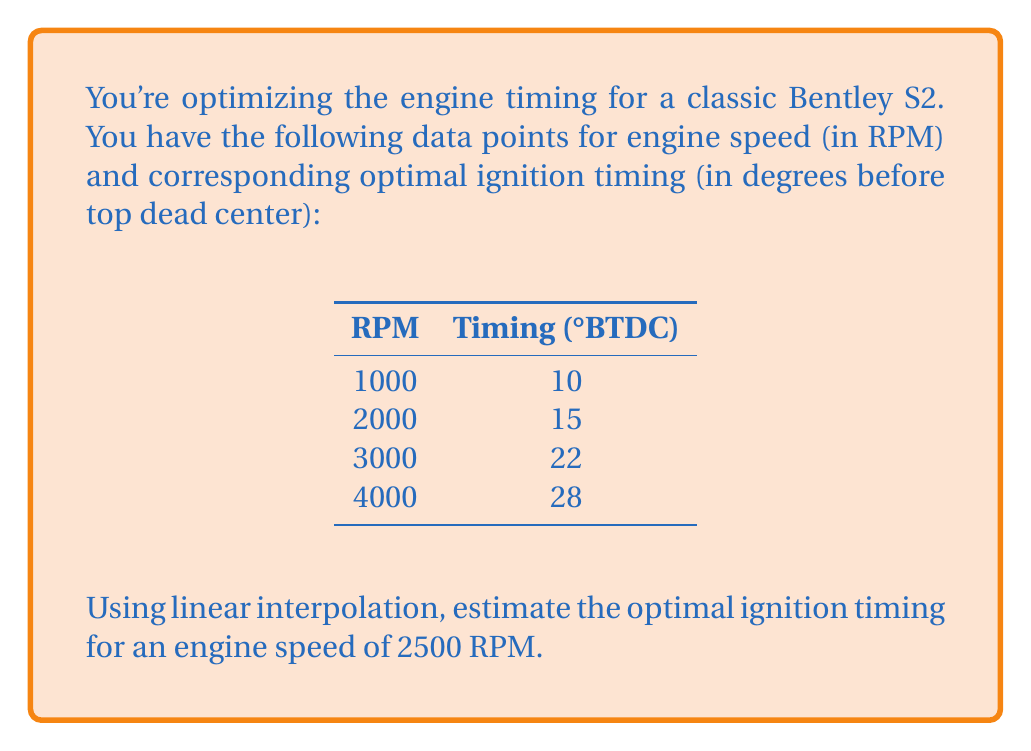Could you help me with this problem? To solve this problem, we'll use linear interpolation between the two closest data points:

1. Identify the two closest data points:
   - Lower point: (2000 RPM, 15°BTDC)
   - Upper point: (3000 RPM, 22°BTDC)

2. Set up the linear interpolation formula:
   $$y = y_1 + \frac{(x - x_1)(y_2 - y_1)}{(x_2 - x_1)}$$

   Where:
   $x$ is the target RPM (2500)
   $(x_1, y_1)$ is the lower point (2000, 15)
   $(x_2, y_2)$ is the upper point (3000, 22)

3. Plug in the values:
   $$y = 15 + \frac{(2500 - 2000)(22 - 15)}{(3000 - 2000)}$$

4. Simplify:
   $$y = 15 + \frac{500 \cdot 7}{1000}$$

5. Calculate:
   $$y = 15 + 3.5 = 18.5$$

Therefore, the estimated optimal ignition timing for 2500 RPM is 18.5°BTDC.
Answer: 18.5°BTDC 